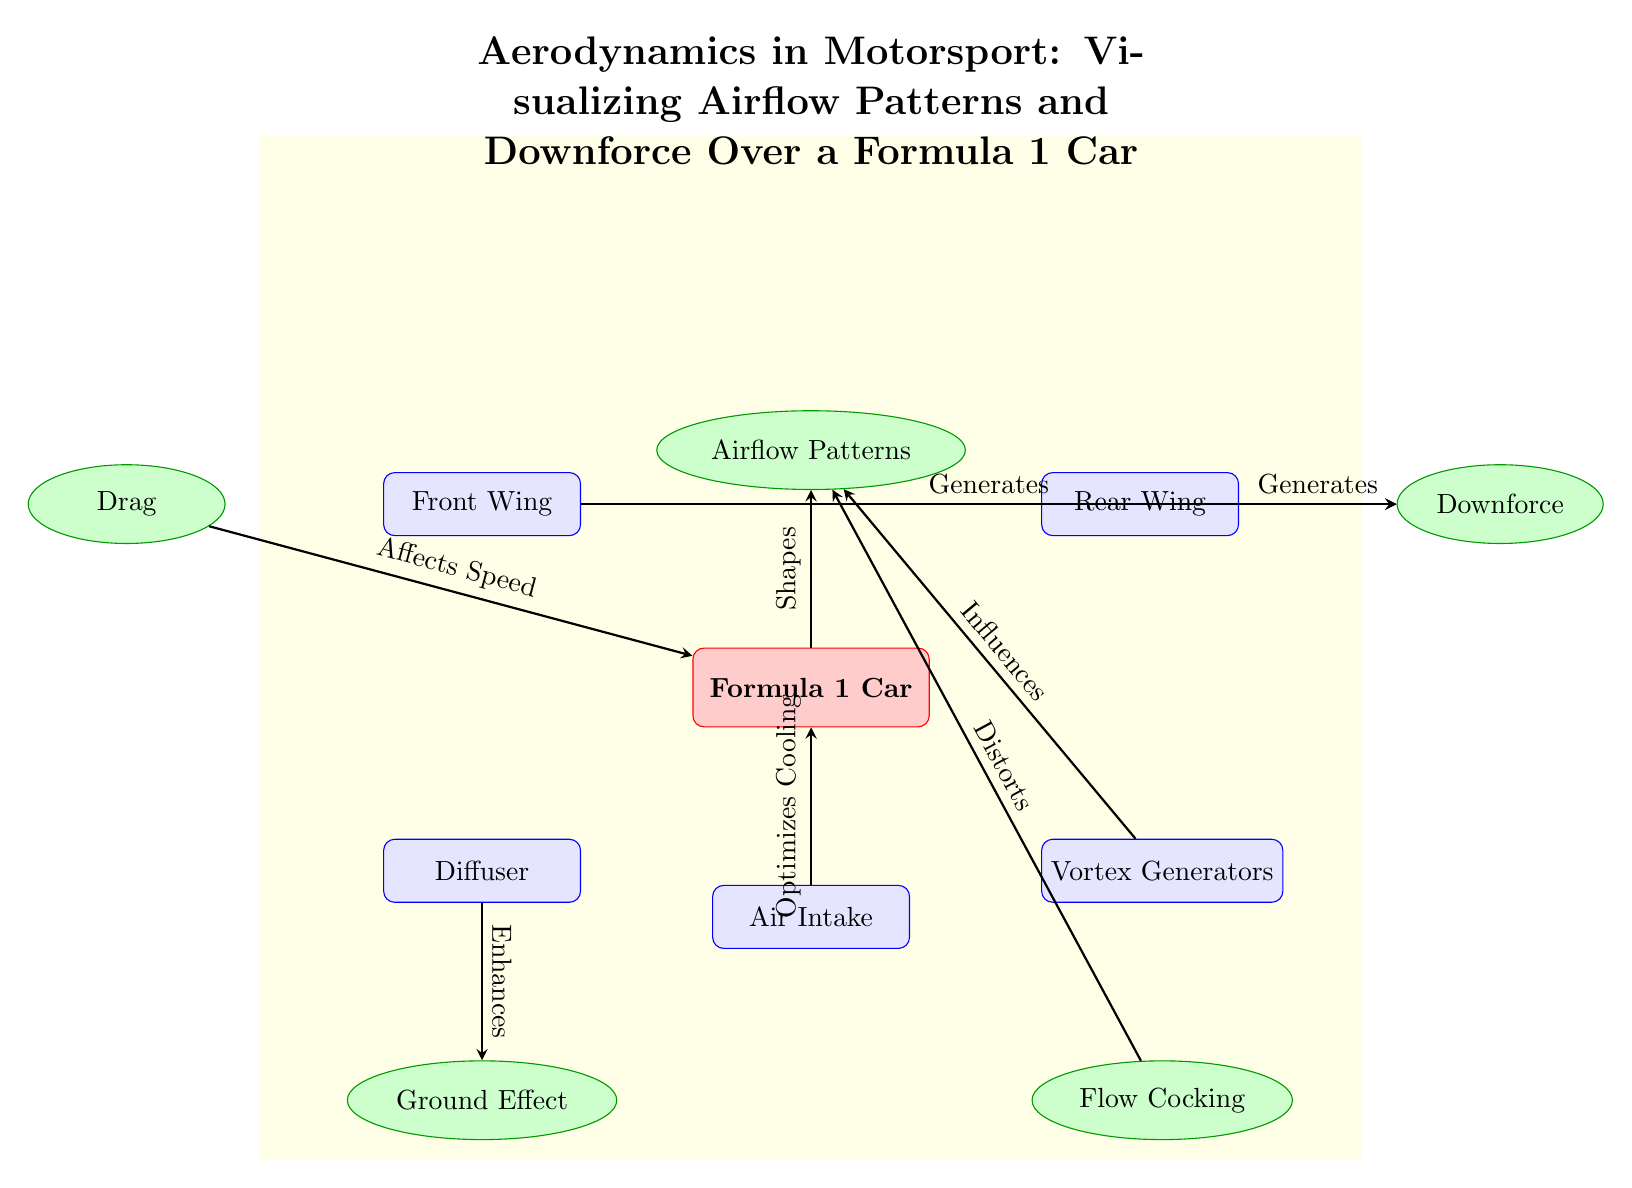What is the main element represented in the diagram? The main element depicted is the "Formula 1 Car", identified as the central node that connects to various aerodynamic parts and concepts.
Answer: Formula 1 Car How many aerodynamic parts are shown in the diagram? There are four aerodynamic parts illustrated: Front Wing, Rear Wing, Diffuser, and Vortex Generators, which are visually represented as blue rectangles.
Answer: 4 What concept does the Front Wing generate? The arrow from the Front Wing to the Downforce indicates that it generates downforce, which is a crucial aerodynamic concept for the car's stability.
Answer: Downforce Which aerodynamic part enhances ground effect? The diagram showcases an arrow from the Diffuser pointing towards Ground Effect, indicating that the Diffuser enhances this aerodynamic feature.
Answer: Diffuser How does the Drag affect the Formula 1 car? The relationship shown by the arrow indicates that Drag affects the speed of the car, highlighting its impact on overall performance.
Answer: Affects Speed Which part influences airflow patterns? The Vortex Generators are shown to influence Airflow Patterns, as indicated by the arrow connecting them in the diagram.
Answer: Vortex Generators What is the purpose of the Air Intake in relation to the Formula 1 Car? The Air Intake is indicated to optimize cooling for the car body, as shown by the directional arrow leading to the car.
Answer: Optimizes Cooling What is visualized above the Formula 1 Car? Airflow Patterns are visualized above the car as a crucial concept that is shaped by the car body, reflecting its aerodynamic design.
Answer: Airflow Patterns How does the Rear Wing contribute to downforce? The Rear Wing also connects to the Downforce as a generating component, similar to the Front Wing, emphasizing its role in aero dynamics.
Answer: Generates Downforce 